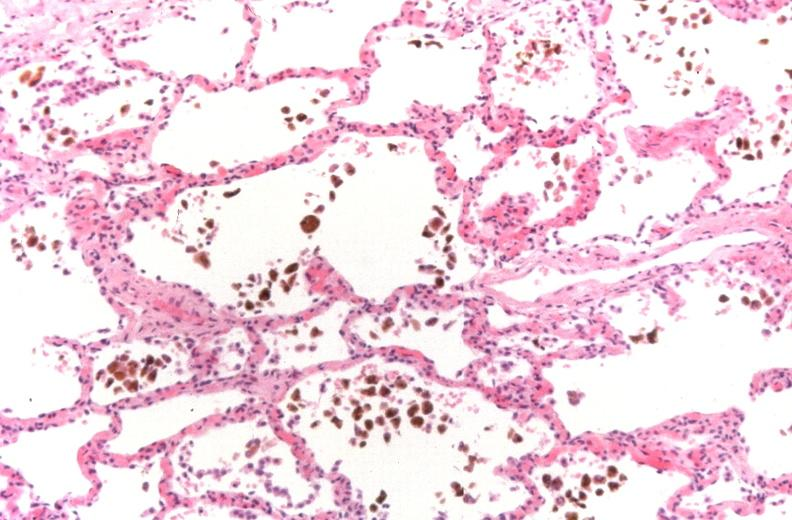s respiratory present?
Answer the question using a single word or phrase. Yes 